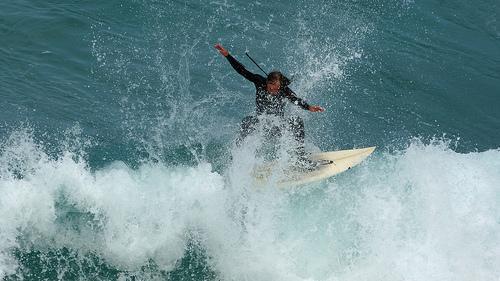How many people are in the picture?
Give a very brief answer. 1. 